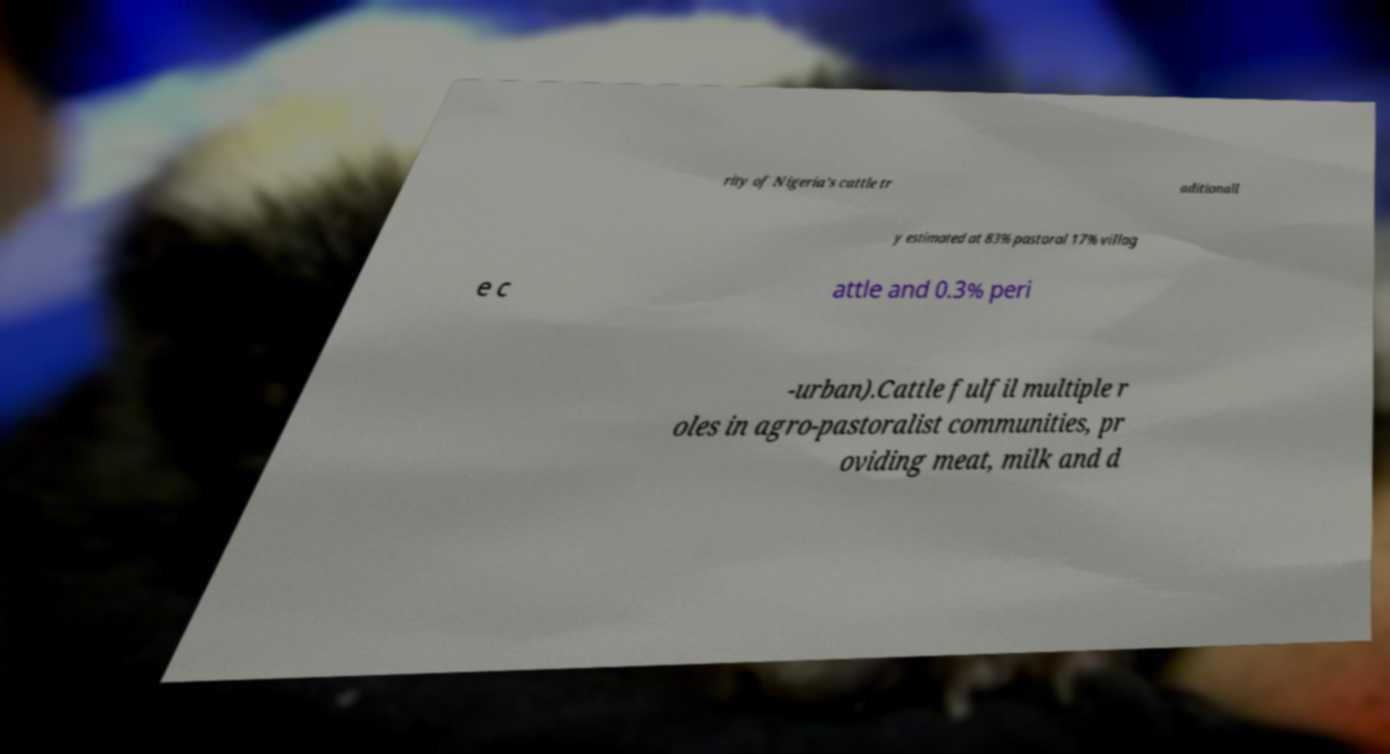I need the written content from this picture converted into text. Can you do that? rity of Nigeria’s cattle tr aditionall y estimated at 83% pastoral 17% villag e c attle and 0.3% peri -urban).Cattle fulfil multiple r oles in agro-pastoralist communities, pr oviding meat, milk and d 